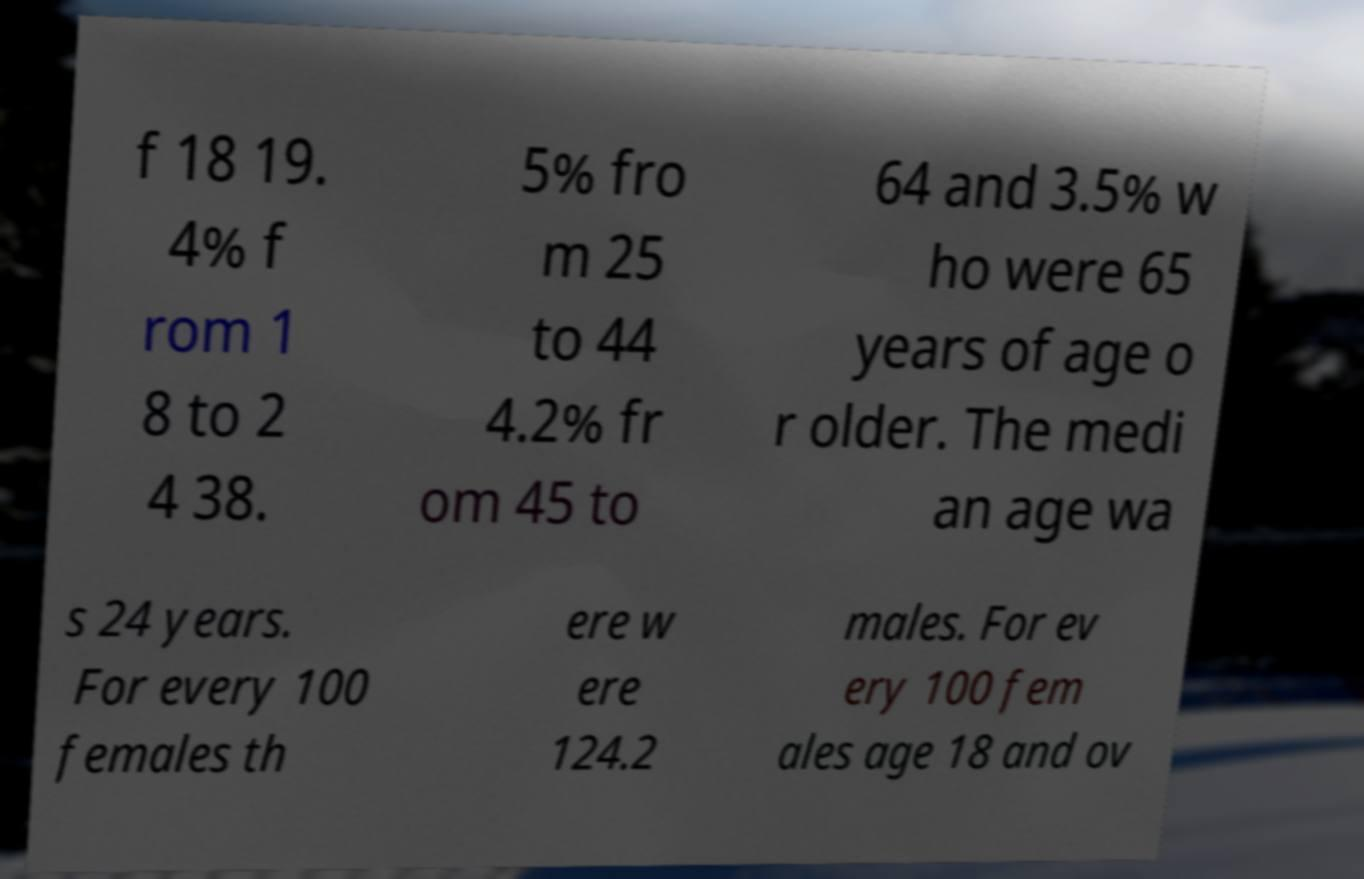Could you extract and type out the text from this image? f 18 19. 4% f rom 1 8 to 2 4 38. 5% fro m 25 to 44 4.2% fr om 45 to 64 and 3.5% w ho were 65 years of age o r older. The medi an age wa s 24 years. For every 100 females th ere w ere 124.2 males. For ev ery 100 fem ales age 18 and ov 